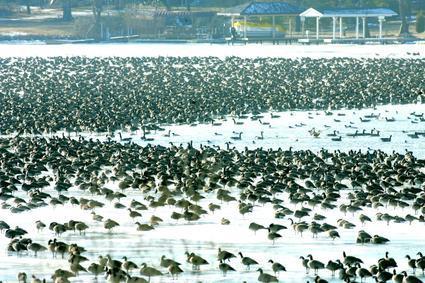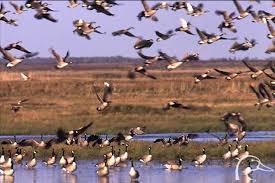The first image is the image on the left, the second image is the image on the right. For the images displayed, is the sentence "In one image, only birds and sky are visible." factually correct? Answer yes or no. No. The first image is the image on the left, the second image is the image on the right. Considering the images on both sides, is "There are no more than 22 birds in one of the images." valid? Answer yes or no. No. 